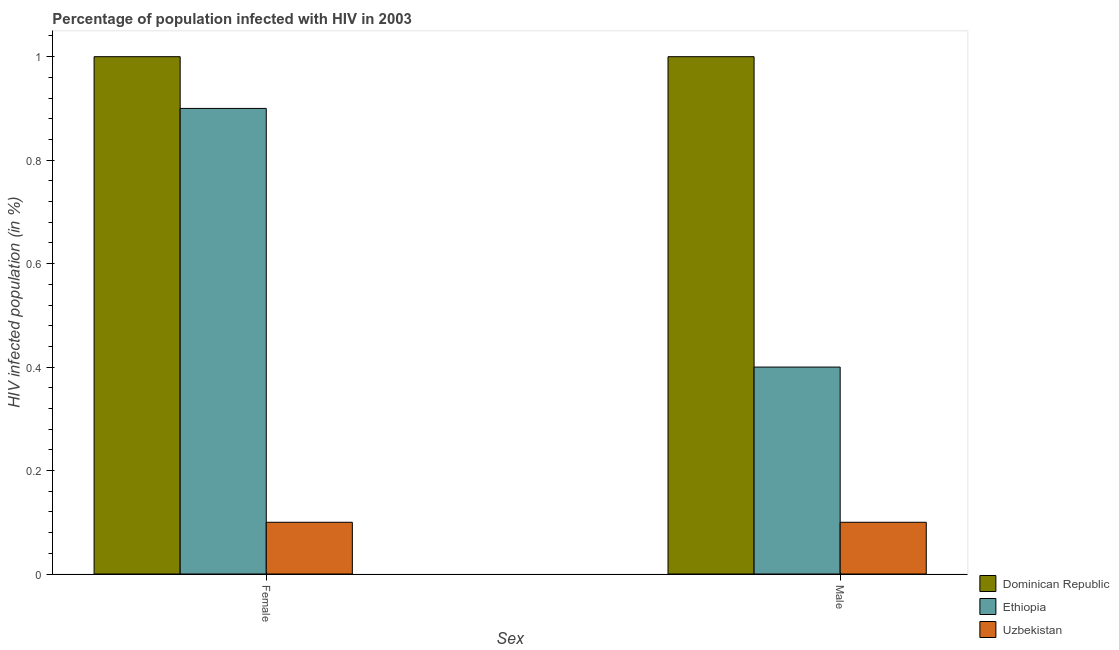How many different coloured bars are there?
Give a very brief answer. 3. How many groups of bars are there?
Your answer should be very brief. 2. Are the number of bars on each tick of the X-axis equal?
Offer a very short reply. Yes. How many bars are there on the 2nd tick from the left?
Provide a short and direct response. 3. How many bars are there on the 1st tick from the right?
Make the answer very short. 3. What is the percentage of females who are infected with hiv in Dominican Republic?
Offer a terse response. 1. In which country was the percentage of females who are infected with hiv maximum?
Provide a short and direct response. Dominican Republic. In which country was the percentage of females who are infected with hiv minimum?
Offer a terse response. Uzbekistan. What is the difference between the percentage of females who are infected with hiv in Dominican Republic and that in Ethiopia?
Your answer should be very brief. 0.1. What is the difference between the percentage of females who are infected with hiv in Ethiopia and the percentage of males who are infected with hiv in Dominican Republic?
Keep it short and to the point. -0.1. What is the average percentage of females who are infected with hiv per country?
Offer a terse response. 0.67. In how many countries, is the percentage of males who are infected with hiv greater than the average percentage of males who are infected with hiv taken over all countries?
Make the answer very short. 1. What does the 2nd bar from the left in Male represents?
Provide a short and direct response. Ethiopia. What does the 3rd bar from the right in Male represents?
Provide a short and direct response. Dominican Republic. How many bars are there?
Your answer should be compact. 6. How many countries are there in the graph?
Make the answer very short. 3. Are the values on the major ticks of Y-axis written in scientific E-notation?
Your response must be concise. No. Does the graph contain grids?
Make the answer very short. No. Where does the legend appear in the graph?
Offer a terse response. Bottom right. What is the title of the graph?
Your answer should be very brief. Percentage of population infected with HIV in 2003. What is the label or title of the X-axis?
Give a very brief answer. Sex. What is the label or title of the Y-axis?
Offer a very short reply. HIV infected population (in %). What is the HIV infected population (in %) of Dominican Republic in Female?
Your answer should be compact. 1. What is the HIV infected population (in %) in Ethiopia in Female?
Ensure brevity in your answer.  0.9. What is the HIV infected population (in %) in Uzbekistan in Female?
Provide a short and direct response. 0.1. What is the HIV infected population (in %) in Uzbekistan in Male?
Make the answer very short. 0.1. Across all Sex, what is the maximum HIV infected population (in %) of Uzbekistan?
Provide a succinct answer. 0.1. Across all Sex, what is the minimum HIV infected population (in %) in Dominican Republic?
Ensure brevity in your answer.  1. Across all Sex, what is the minimum HIV infected population (in %) in Ethiopia?
Ensure brevity in your answer.  0.4. Across all Sex, what is the minimum HIV infected population (in %) of Uzbekistan?
Provide a succinct answer. 0.1. What is the total HIV infected population (in %) of Ethiopia in the graph?
Ensure brevity in your answer.  1.3. What is the difference between the HIV infected population (in %) in Ethiopia in Female and that in Male?
Offer a very short reply. 0.5. What is the difference between the HIV infected population (in %) of Uzbekistan in Female and that in Male?
Provide a short and direct response. 0. What is the difference between the HIV infected population (in %) in Dominican Republic in Female and the HIV infected population (in %) in Ethiopia in Male?
Make the answer very short. 0.6. What is the difference between the HIV infected population (in %) in Dominican Republic in Female and the HIV infected population (in %) in Uzbekistan in Male?
Offer a very short reply. 0.9. What is the difference between the HIV infected population (in %) of Ethiopia in Female and the HIV infected population (in %) of Uzbekistan in Male?
Make the answer very short. 0.8. What is the average HIV infected population (in %) in Dominican Republic per Sex?
Your answer should be compact. 1. What is the average HIV infected population (in %) in Ethiopia per Sex?
Make the answer very short. 0.65. What is the average HIV infected population (in %) in Uzbekistan per Sex?
Give a very brief answer. 0.1. What is the difference between the HIV infected population (in %) of Dominican Republic and HIV infected population (in %) of Ethiopia in Female?
Provide a succinct answer. 0.1. What is the difference between the HIV infected population (in %) of Dominican Republic and HIV infected population (in %) of Uzbekistan in Female?
Provide a succinct answer. 0.9. What is the difference between the HIV infected population (in %) in Ethiopia and HIV infected population (in %) in Uzbekistan in Female?
Ensure brevity in your answer.  0.8. What is the difference between the HIV infected population (in %) of Dominican Republic and HIV infected population (in %) of Uzbekistan in Male?
Provide a succinct answer. 0.9. What is the ratio of the HIV infected population (in %) in Ethiopia in Female to that in Male?
Your response must be concise. 2.25. What is the ratio of the HIV infected population (in %) in Uzbekistan in Female to that in Male?
Give a very brief answer. 1. What is the difference between the highest and the second highest HIV infected population (in %) of Dominican Republic?
Your answer should be compact. 0. What is the difference between the highest and the second highest HIV infected population (in %) in Uzbekistan?
Provide a short and direct response. 0. What is the difference between the highest and the lowest HIV infected population (in %) of Dominican Republic?
Provide a succinct answer. 0. 